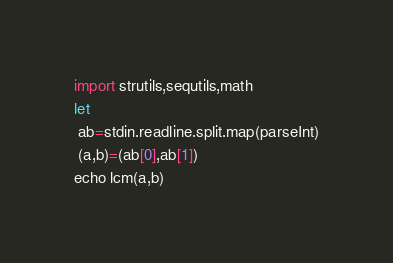<code> <loc_0><loc_0><loc_500><loc_500><_Nim_>import strutils,sequtils,math
let
 ab=stdin.readline.split.map(parseInt)
 (a,b)=(ab[0],ab[1])
echo lcm(a,b)</code> 